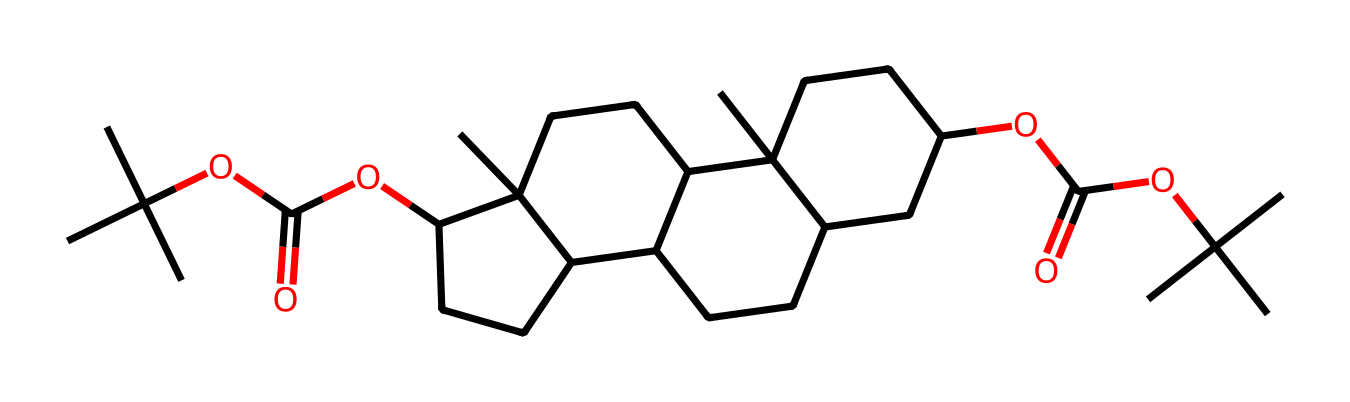What is the total number of carbon atoms in this structure? By analyzing the SMILES representation, I can observe that the structure consists of various carbon atoms denoted by "C." Counting each "C" in the SMILES string indicates a total of 30 carbon atoms present in the structure.
Answer: 30 How many ester functional groups are present in this compound? In the given SMILES, the ester groups can be identified by the presence of "C(=O)O" segments. Scanning through the structure, I find two instances of this configuration, indicating that there are two ester functional groups in total.
Answer: 2 What characteristic feature identifies this compound as a cycloalkane? This compound can be identified as a cycloalkane because it has multiple interconnected cyclic structures. The presence of "C" atoms arranged in cyclical arrangements throughout the SMILES confirms it aligns with the definition of cycloalkanes.
Answer: cyclical structures What is the degree of saturation of this cycloalkane compound? The degree of saturation can be derived from the general formula for cycloalkanes, which is CnH2n. In this case, with 30 carbons, the formula gives C30H60, but due to the presence of ester groups, we need to account for them. A total of 28 hydrogens are calculated based on the connections, indicating a high degree of saturation overall despite some hydrogen atoms being replaced by functional groups.
Answer: high Does this chemical structure exhibit any symmetrical properties? Analyzing the rendered structure visually or through its SMILES representation shows a balanced arrangement of carbon atoms around the ring structures, providing symmetry in the overall molecular configuration. This symmetry is an essential feature, especially in specific cycloalkane derivatives.
Answer: yes 